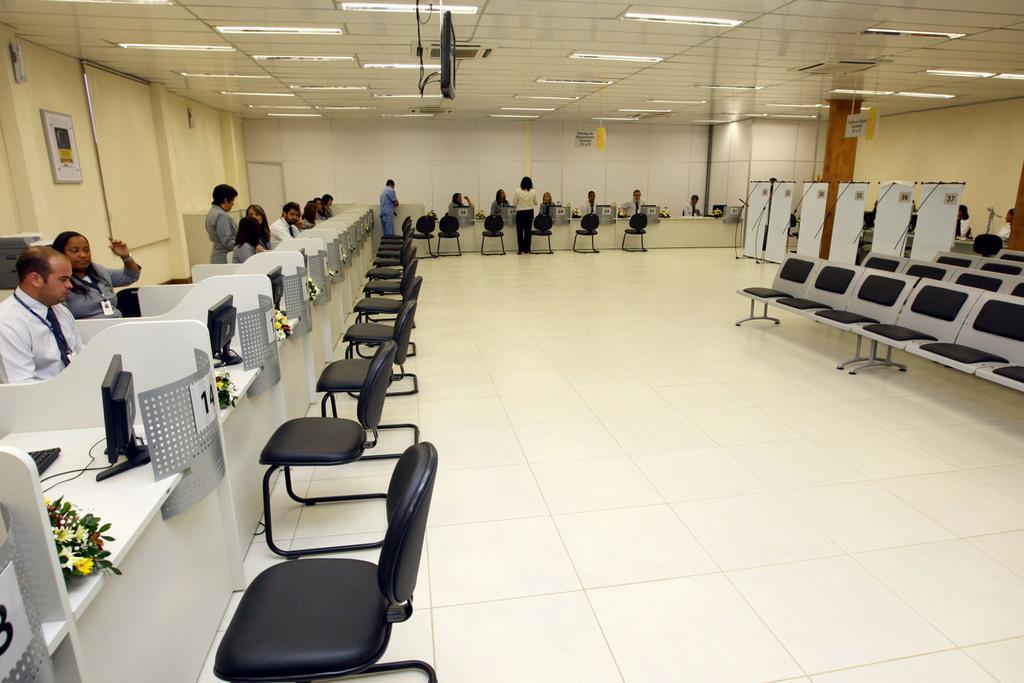In one or two sentences, can you explain what this image depicts? In this image I can see group of people, some are sitting and some are standing. In front I can see few systems and I can also see few chairs in black color. In the background I can see the wall in cream and white color. 